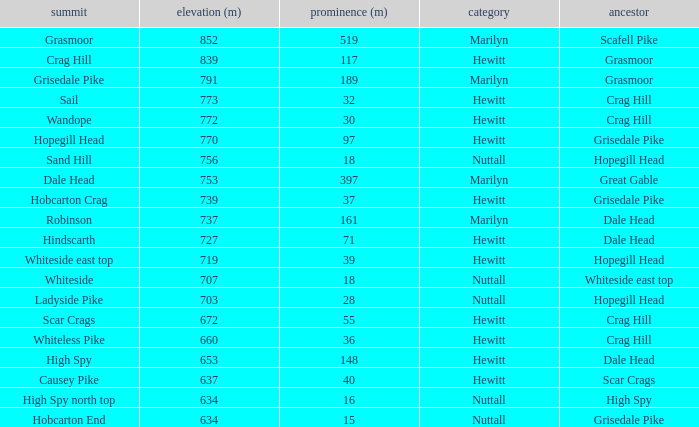Which Class is Peak Sail when it has a Prom larger than 30? Hewitt. 